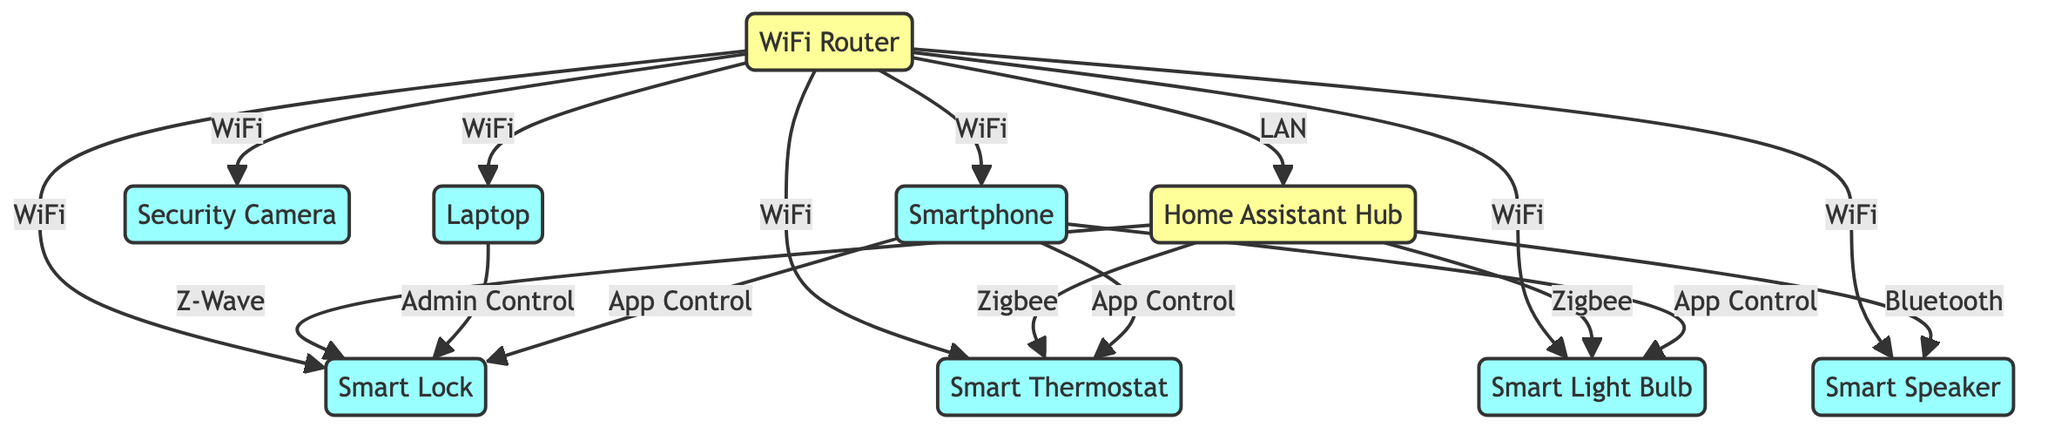What is the total number of nodes in the diagram? The diagram contains a list of nodes that includes the WiFi Router, Smart Lock, Smart Thermostat, Smart Light Bulb, Smart Speaker, Home Assistant Hub, Security Camera, Laptop, and Smartphone. Counting these, we find there are 9 nodes in total.
Answer: 9 What connects the Smart Lock directly to the WiFi Router? The Smart Lock is connected to the WiFi Router directly via a WiFi connection, as indicated by the labeled edge between these two nodes.
Answer: WiFi How many devices connect to the Home Assistant Hub? The Home Assistant Hub has connections to four devices: Smart Lock, Smart Thermostat, Smart Light Bulb, and Smart Speaker. By counting these connections, we determine it connects to 4 devices.
Answer: 4 Which device is controlled by the Smartphone through App Control? The Smartphone connects to multiple devices through App Control, specifically the Smart Lock, Smart Thermostat, and Smart Light Bulb. Thus, one device that is controlled is the Smart Lock, but there are others too.
Answer: Smart Lock What type of connection links the Laptop to the Smart Lock? The edge between the Laptop and the Smart Lock is labeled "Admin Control," indicating this specific type of connection used for controlling the Smart Lock from the Laptop.
Answer: Admin Control What are the two connection types from the Home Assistant Hub to other devices? The Home Assistant Hub connects to devices using Z-Wave to the Smart Lock and Zigbee to the Smart Thermostat and Smart Light Bulb, and Bluetooth to the Smart Speaker, indicating multiple types of connectivity.
Answer: Z-Wave and Zigbee Is the Security Camera connected to the Home Assistant Hub? On examining the connections, the Security Camera is connected directly to the WiFi Router but not to the Home Assistant Hub, indicating that it isn't linked to the Hub.
Answer: No Which device does not connect directly to the Home Assistant Hub? The Smart Speaker connects to the Home Assistant Hub via Bluetooth, while the Security Camera and Smart Lock connect only to the WiFi Router, revealing that the Security Camera is the device not directly connected to the Hub.
Answer: Security Camera 